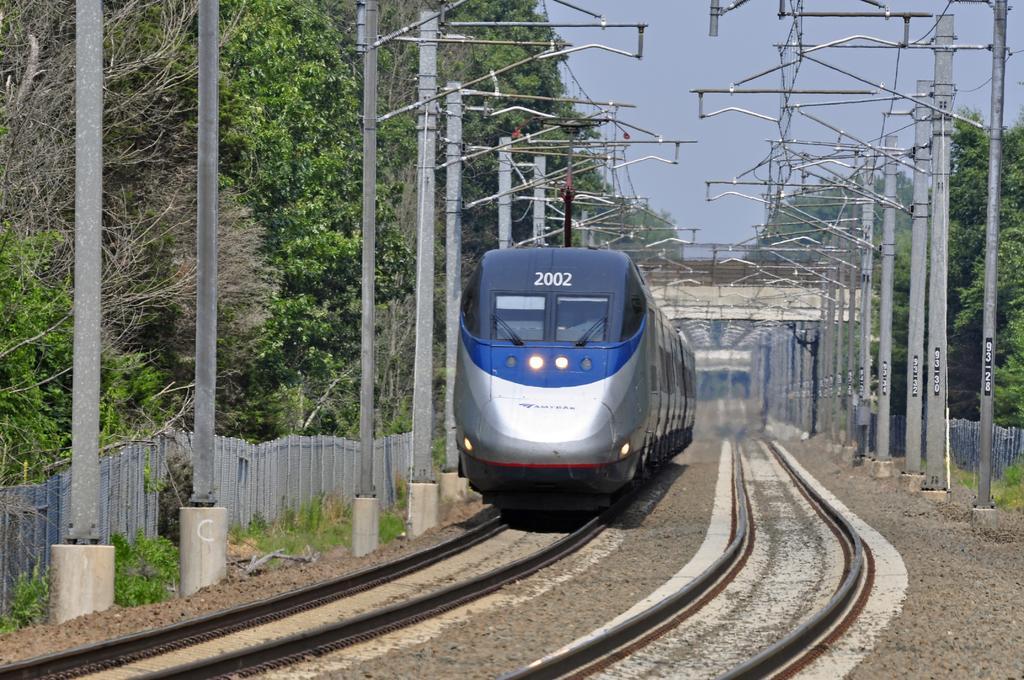Can you describe this image briefly? We can see train on track and we can see poles with wires, grass and trees. On the background we can see bridge and sky. 